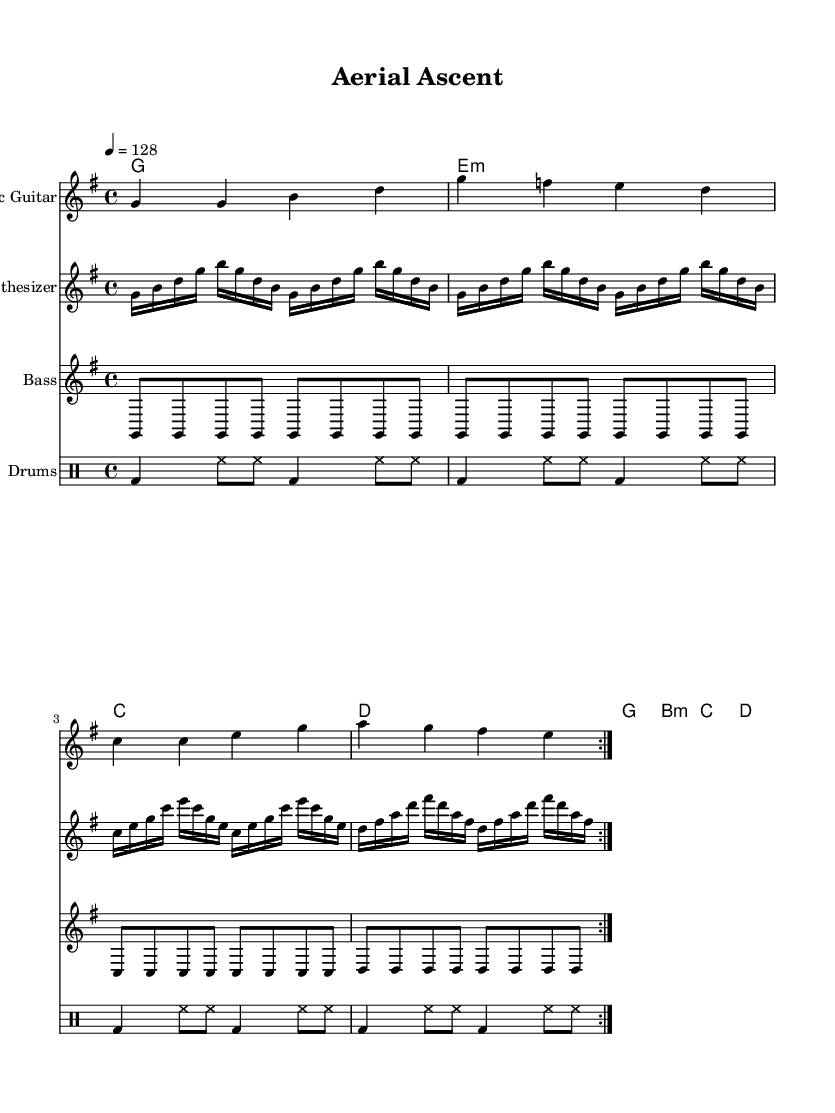What is the key signature of this music? The key signature is represented by the sharps or flats indicated at the beginning of the staff. In this sheet music, there are no sharps or flats, indicating that the key signature is G major, which has one sharp (F#).
Answer: G major What is the time signature of the music? The time signature is shown at the beginning of the score and indicates how many beats are in each measure. In this case, the time signature is 4/4, which means there are four beats per measure.
Answer: 4/4 What is the tempo marking of this composition? The tempo is indicated within the score, specifying the speed of the music. Here, it states "4 = 128," meaning there are 128 beats per minute at quarter note equals 4.
Answer: 128 How many measures are there in the electric guitar part? To find the total number of measures, one can count the measures indicated in the electric guitar part and take into account the repeats. There are 8 measures due to the repeats marked in the score.
Answer: 8 What is the primary instrumental role of the synthesizer in this piece? By analyzing the synthesizer part, it plays fast-paced arpeggios that complement the chord structure, primarily providing harmonic support and energy to the rhythm of the piece.
Answer: Harmonies What chord is played in the first measure? The first measure contains a G major chord, which consists of the notes G, B, and D. This is determined by looking at the chord symbols directly above the measures.
Answer: G What type of rhythm pattern is predominantly used in the drum part? The drum part features a repetitive eighth-note hi-hat pattern accompanied by bass drum hits, which creates an energetic and driving rhythm characteristic of upbeat pop music.
Answer: Repetitive eighth-notes 